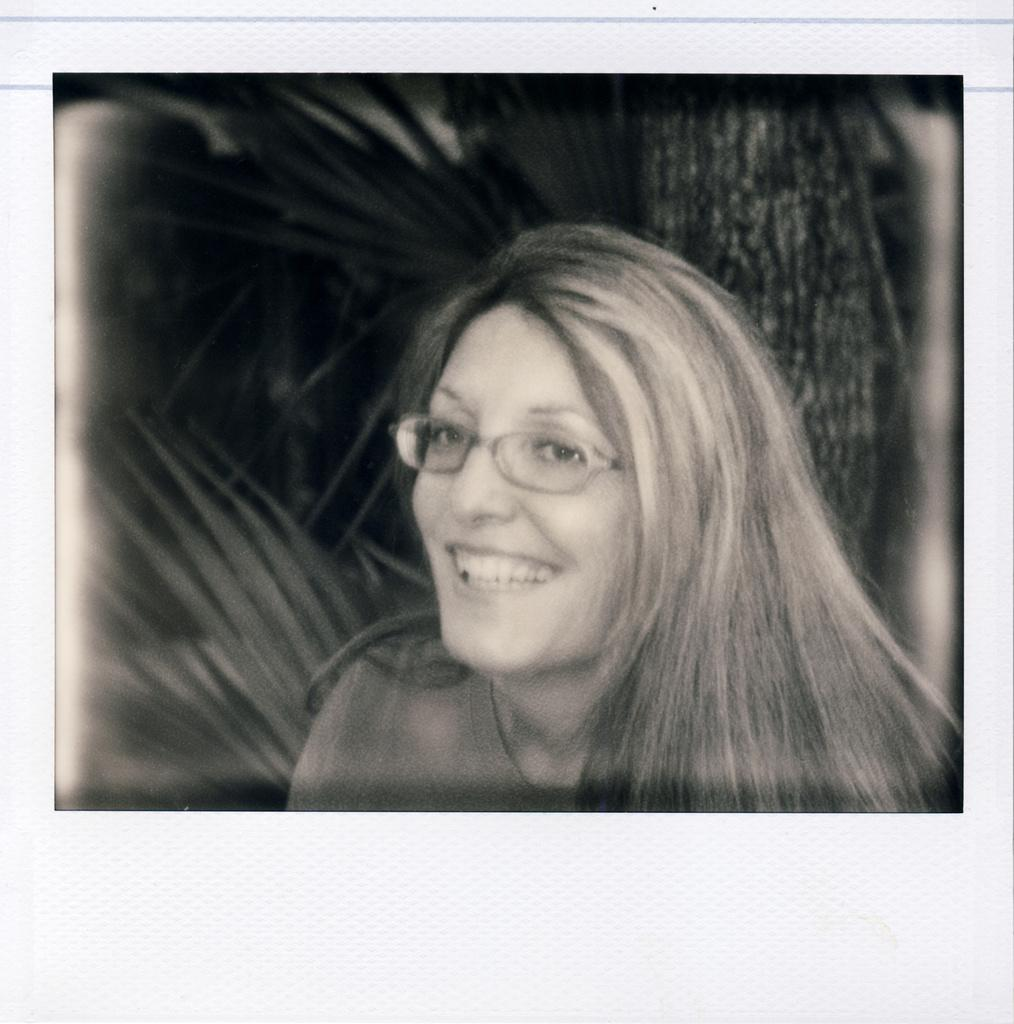How has the image been altered? The image is edited and black and white. What is the primary subject in the image? There is a woman in the image. What is the woman doing in the image? The woman is laughing. What is the name of the writer in the image? There is no writer present in the image; it features a woman laughing. What direction is the actor facing in the image? There is no actor present in the image; it features a woman laughing. 